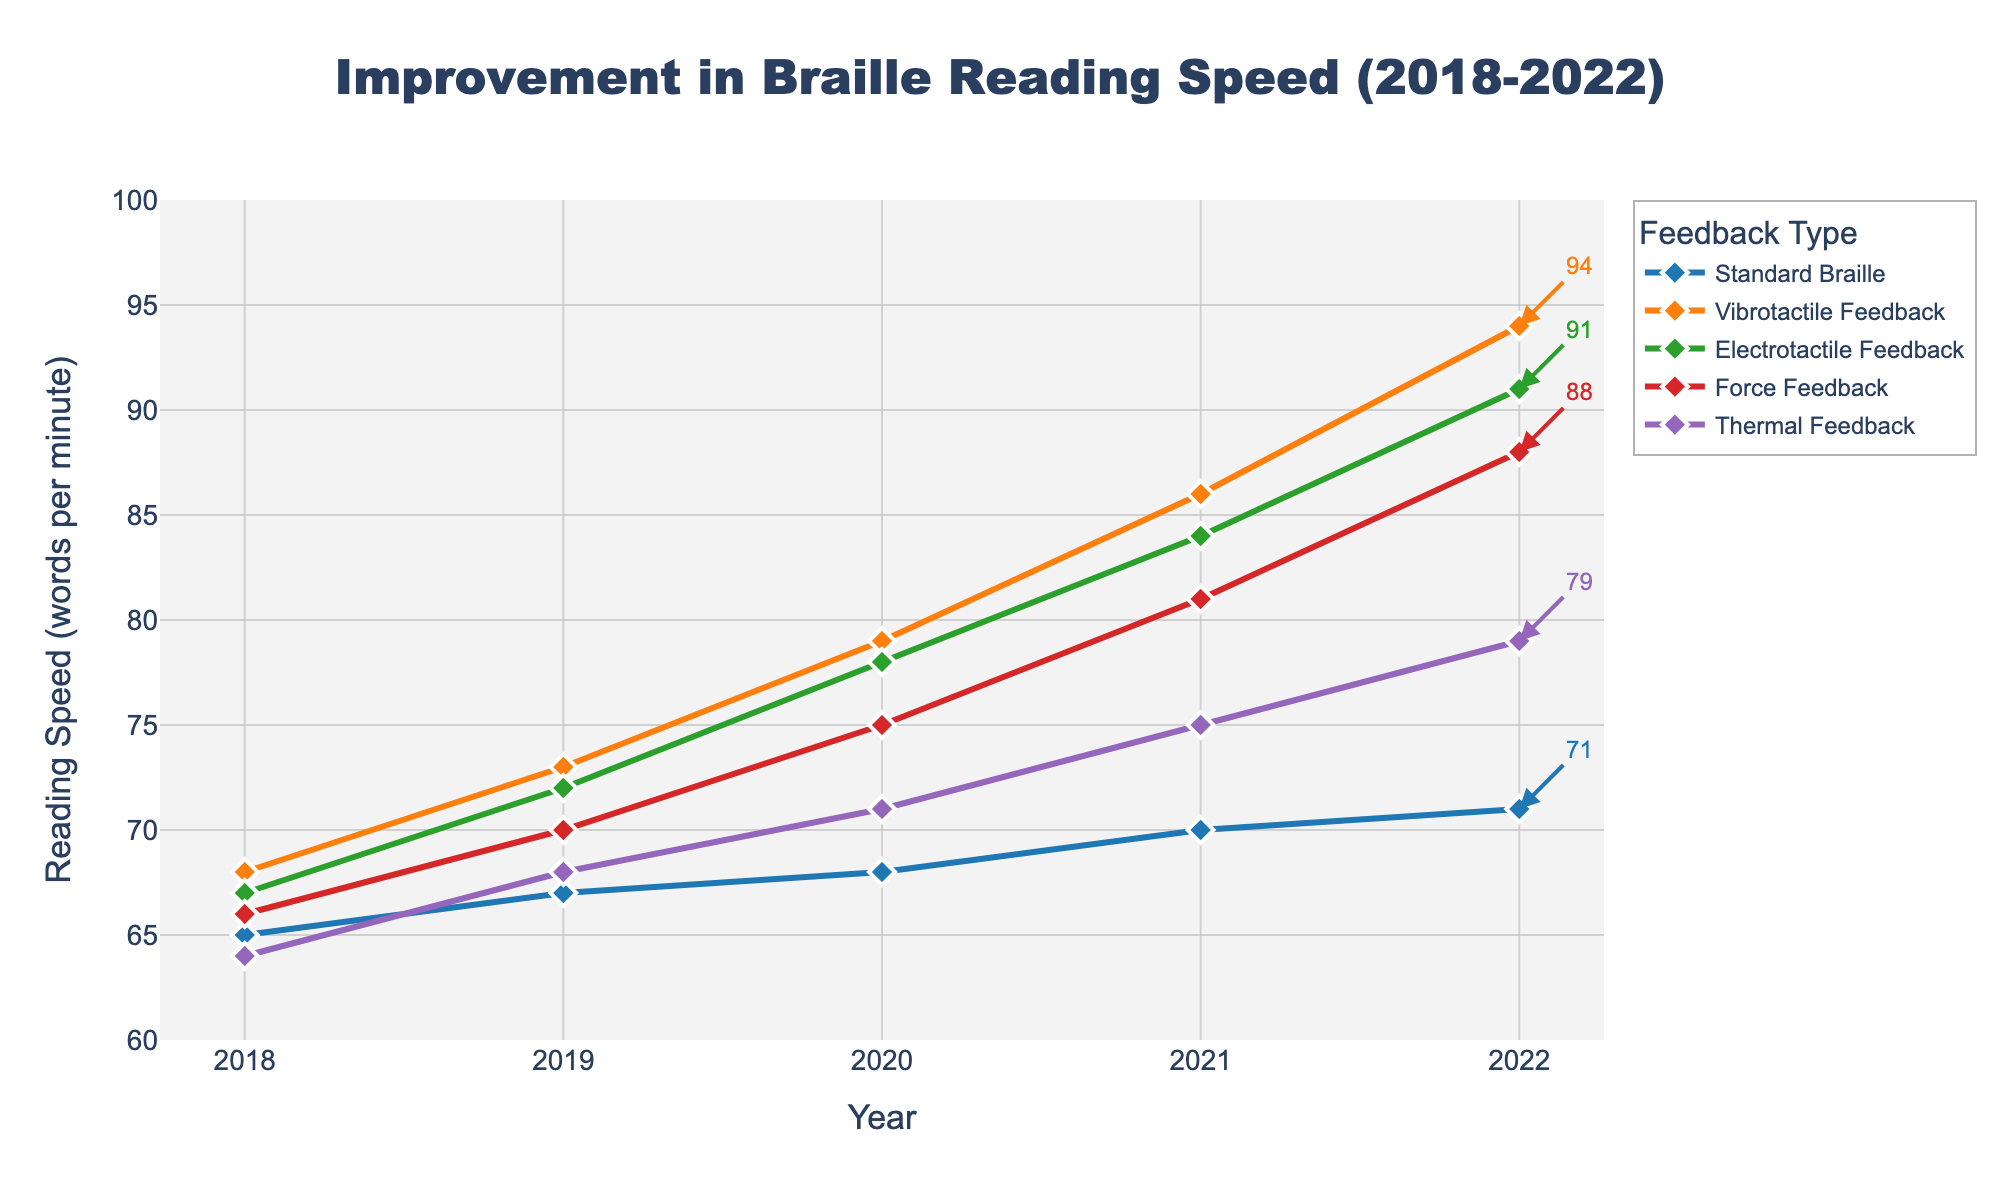What is the trend for the Vibrotactile Feedback reading speed from 2018 to 2022? The lines for Vibrotactile Feedback start at 68 in 2018 and steadily increase to 94 by 2022. It shows consistent improvement over this period.
Answer: Increasing Which feedback type had the highest reading speed in 2021? By examining the lines corresponding to each year, 2021 shows Electrotactile Feedback has the highest value (84).
Answer: Electrotactile Feedback What’s the difference in reading speed for Force Feedback between 2018 and 2022? Looking at the data points for Force Feedback, in 2018 it was 66 and in 2022 it is 88. So, 88 - 66 = 22.
Answer: 22 Which year had the smallest improvement in Standard Braille reading speed? The improvement for Standard Braille is 67 - 65 = 2 from 2018 to 2019 which is the smallest compared to other years.
Answer: 2018-2019 Does Thermal Feedback ever surpass Standard Braille reading speed? Comparing the values year over year, the line for Standard Braille is always above the line for Thermal Feedback.
Answer: No Which feedback type shows the most improvement from 2018 to 2022? Calculating the increase for each feedback type from 2018 to 2022: Standard Braille (71-65=6), Vibrotactile (94-68=26), Electrotactile (91-67=24), Force (88-66=22), Thermal (79-64=15). Vibrotactile Feedback shows the most improvement.
Answer: Vibrotactile Feedback What was the average reading speed for Electrotactile Feedback over the 5-year period? Summing the reading speeds for Electrotactile Feedback from 2018 to 2022 (67 + 72 + 78 + 84 + 91 = 392), then dividing by 5: 392/5 = 78.4.
Answer: 78.4 How much did the Thermal Feedback reading speed improve from 2019 to 2021? The reading speed for Thermal Feedback in 2019 was 68 and in 2021 it was 75. The difference is 75 - 68 = 7.
Answer: 7 